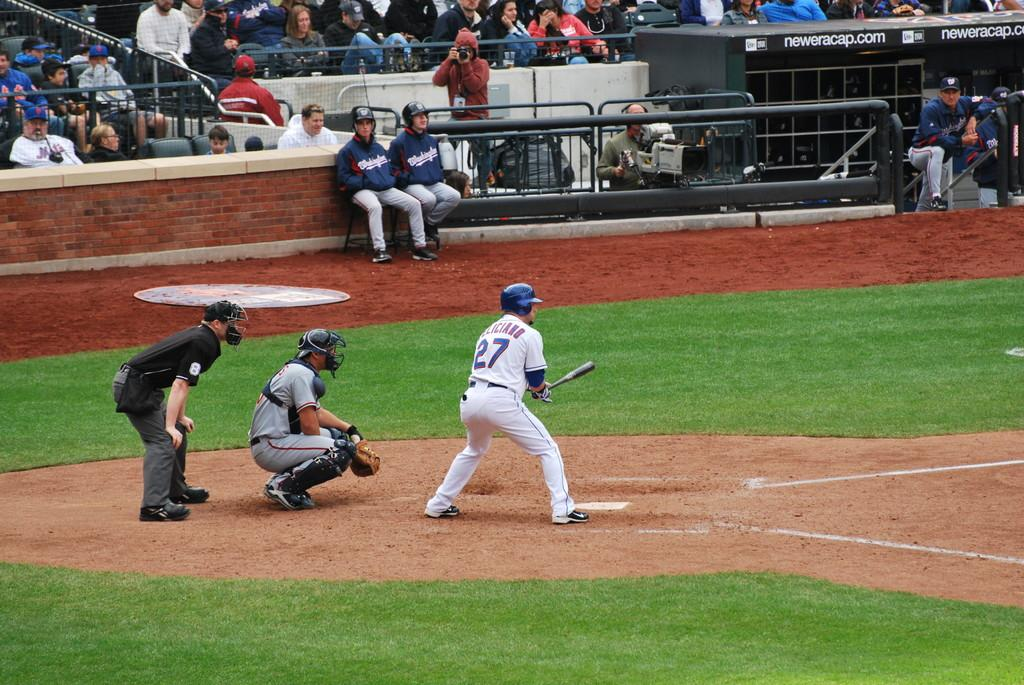<image>
Offer a succinct explanation of the picture presented. A man wearing a jersey with the number 27 holds a baseball bat over home plate. 